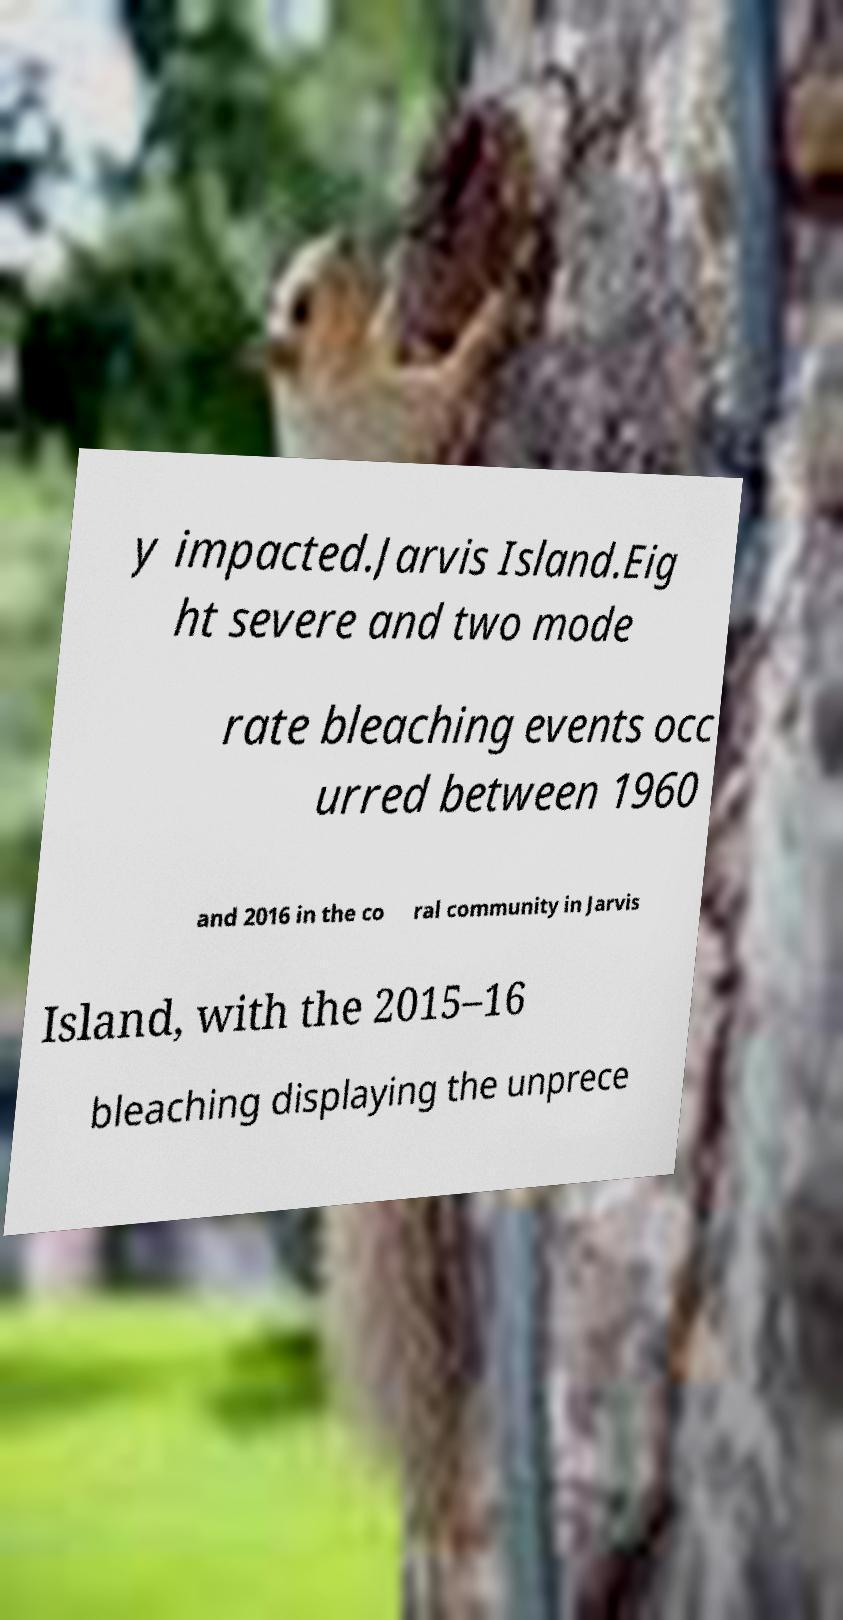Could you assist in decoding the text presented in this image and type it out clearly? y impacted.Jarvis Island.Eig ht severe and two mode rate bleaching events occ urred between 1960 and 2016 in the co ral community in Jarvis Island, with the 2015–16 bleaching displaying the unprece 